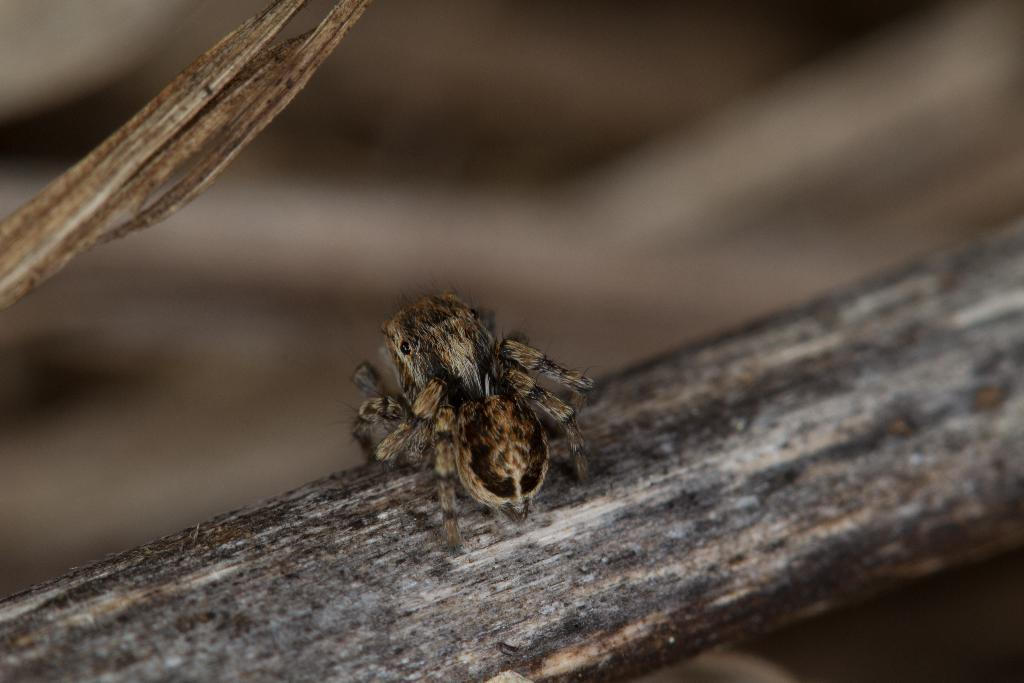What type of creature can be seen in the image? There is an insect in the image. Where is the insect located in the image? The insect is on a stick. How many toes can be seen on the insect in the image? Insects do not have toes, so none can be seen on the insect in the image. 